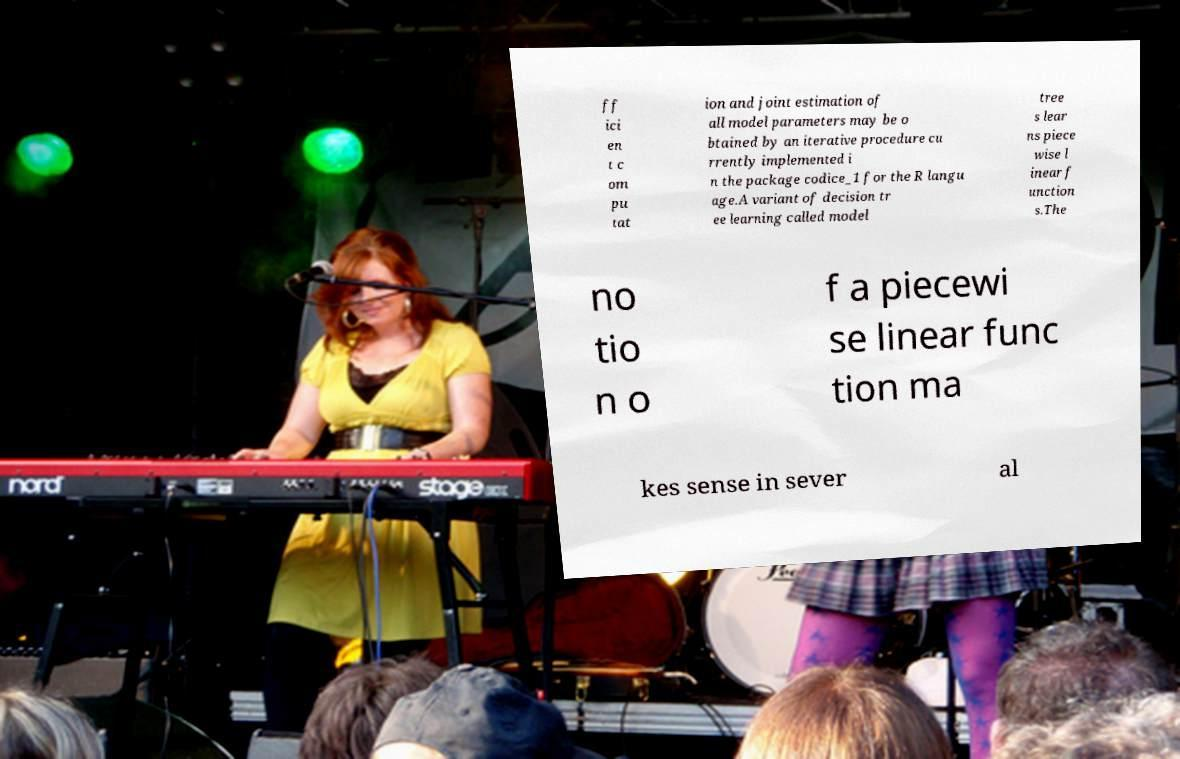Can you read and provide the text displayed in the image?This photo seems to have some interesting text. Can you extract and type it out for me? ff ici en t c om pu tat ion and joint estimation of all model parameters may be o btained by an iterative procedure cu rrently implemented i n the package codice_1 for the R langu age.A variant of decision tr ee learning called model tree s lear ns piece wise l inear f unction s.The no tio n o f a piecewi se linear func tion ma kes sense in sever al 